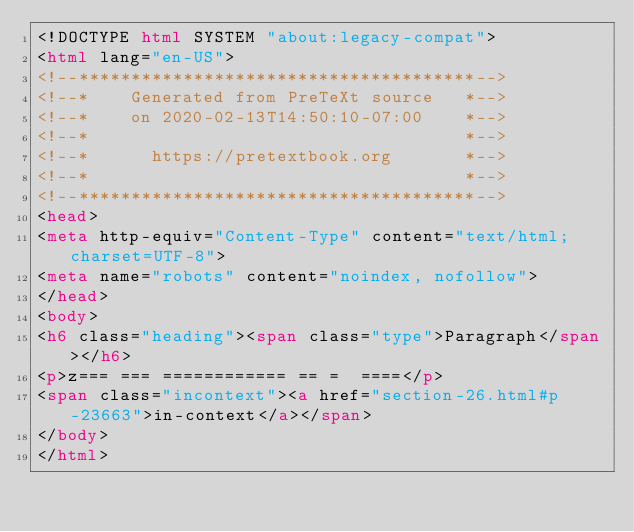<code> <loc_0><loc_0><loc_500><loc_500><_HTML_><!DOCTYPE html SYSTEM "about:legacy-compat">
<html lang="en-US">
<!--**************************************-->
<!--*    Generated from PreTeXt source   *-->
<!--*    on 2020-02-13T14:50:10-07:00    *-->
<!--*                                    *-->
<!--*      https://pretextbook.org       *-->
<!--*                                    *-->
<!--**************************************-->
<head>
<meta http-equiv="Content-Type" content="text/html; charset=UTF-8">
<meta name="robots" content="noindex, nofollow">
</head>
<body>
<h6 class="heading"><span class="type">Paragraph</span></h6>
<p>z=== === ============ == =  ====</p>
<span class="incontext"><a href="section-26.html#p-23663">in-context</a></span>
</body>
</html>
</code> 